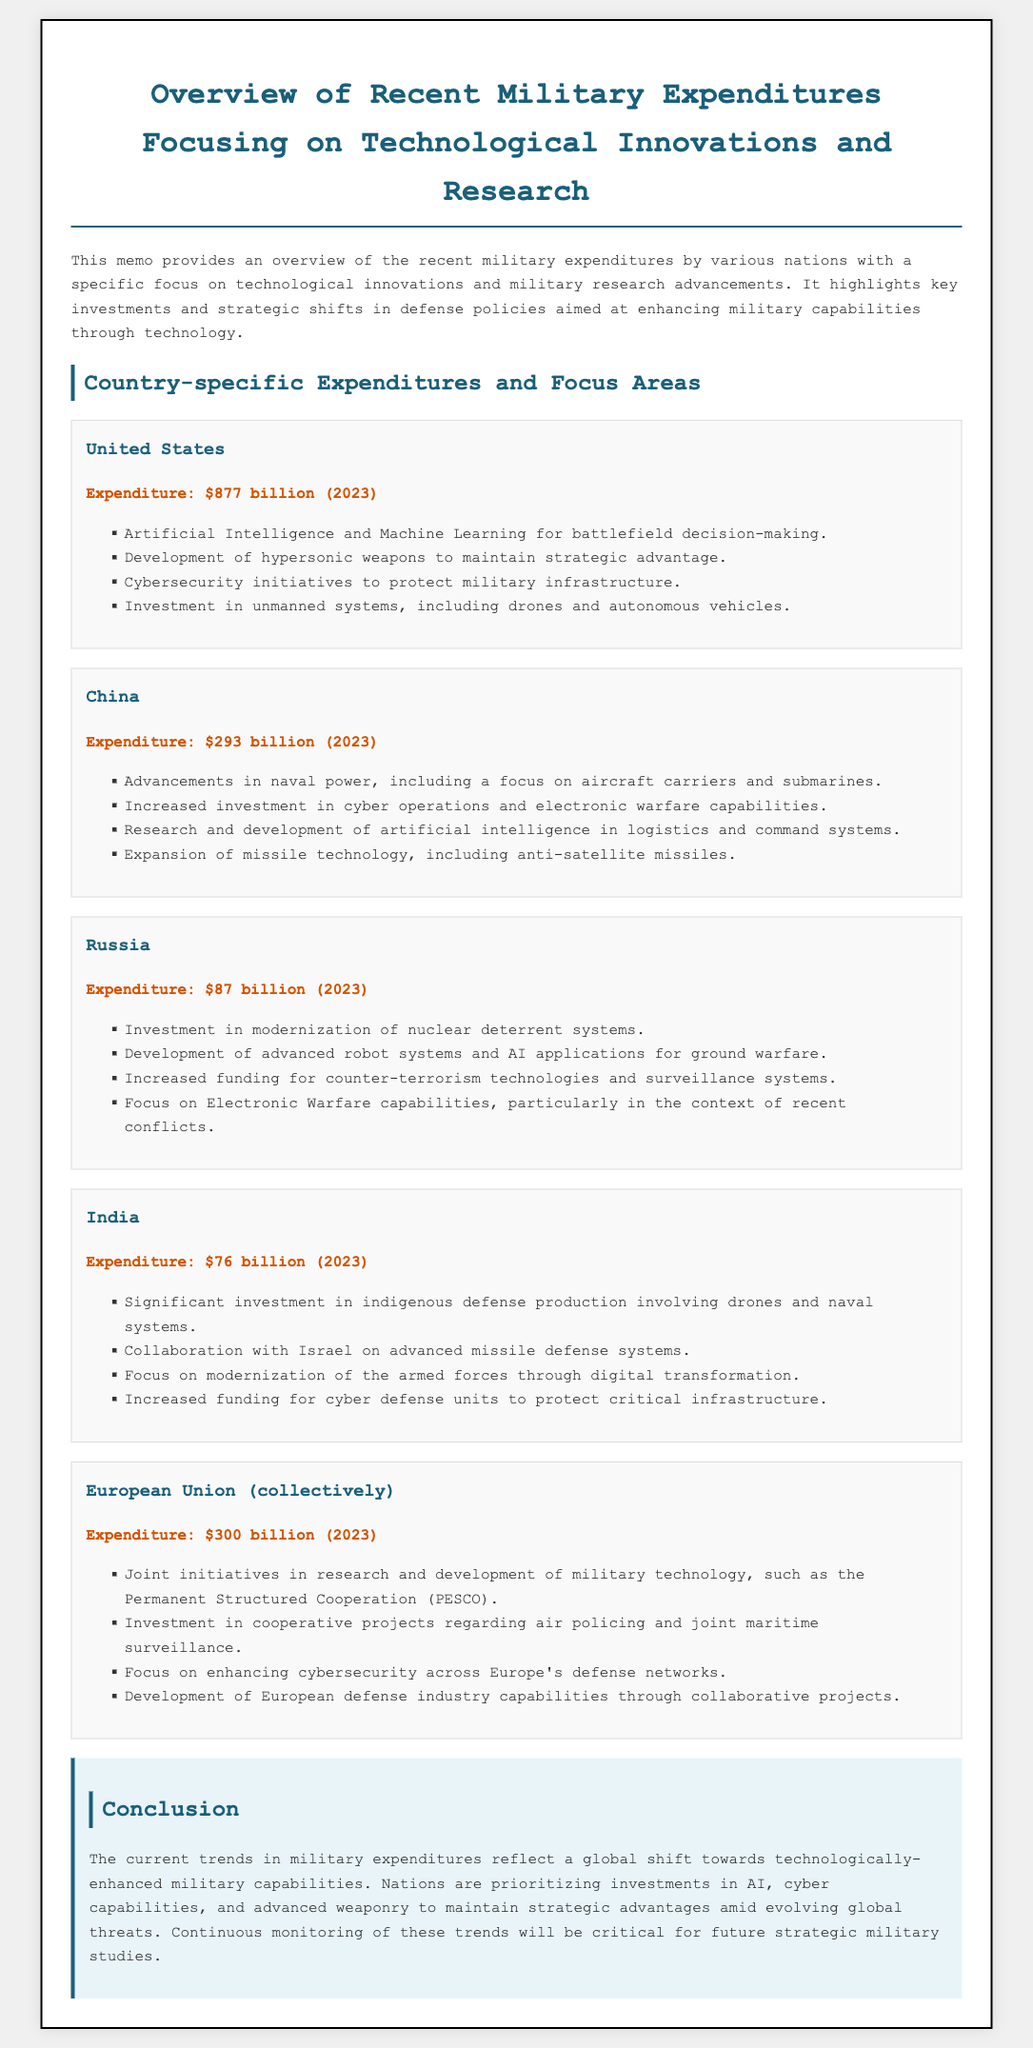What is the expenditure of the United States? The document states that the expenditure of the United States for 2023 is $877 billion.
Answer: $877 billion Which country has an expenditure of $76 billion? The document lists India's expenditure as $76 billion for 2023.
Answer: India What major focus area does Russia emphasize in its military expenditures? The document notes Russia's emphasis on the modernization of nuclear deterrent systems.
Answer: Modernization of nuclear deterrent systems What technological area is the European Union collectively investing in? The memo mentions that the EU is investing in cooperative projects for joint maritime surveillance.
Answer: Joint maritime surveillance Which country is collaborating with Israel on missile defense systems? The document identifies India as collaborating with Israel on advanced missile defense systems.
Answer: India What is a significant trend noted in the conclusion of the memo? The conclusion highlights a shift towards technologically-enhanced military capabilities.
Answer: Technologically-enhanced military capabilities What specific technology is highlighted in the United States' military focus? The document states that the U.S. is investing in artificial intelligence and machine learning for battlefield decision-making.
Answer: Artificial intelligence and machine learning What type of projects is the European Union pursuing under PESCO? The document indicates that the EU is engaged in research and development of military technology through PESCO.
Answer: Research and development of military technology What is the total expenditure of China in 2023? The document provides that China’s expenditure for 2023 is $293 billion.
Answer: $293 billion 